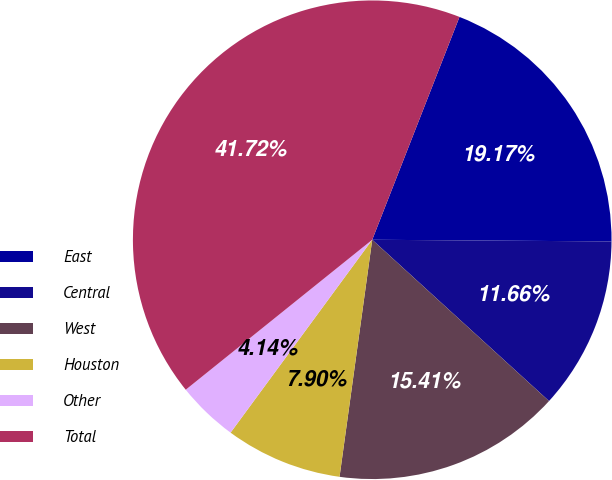<chart> <loc_0><loc_0><loc_500><loc_500><pie_chart><fcel>East<fcel>Central<fcel>West<fcel>Houston<fcel>Other<fcel>Total<nl><fcel>19.17%<fcel>11.66%<fcel>15.41%<fcel>7.9%<fcel>4.14%<fcel>41.72%<nl></chart> 